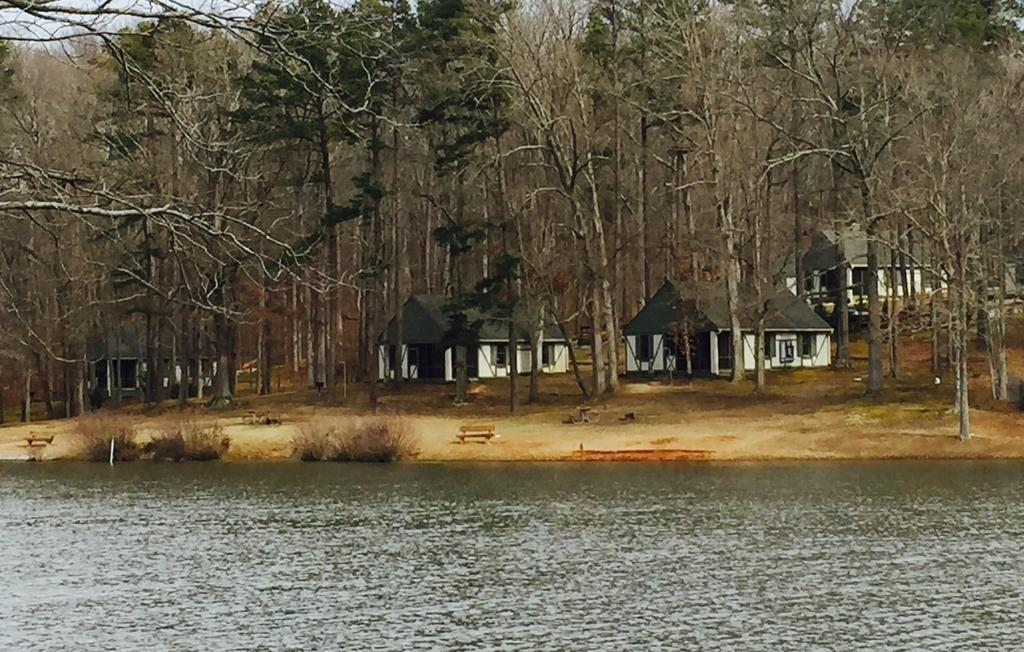Where was the image taken? The image was clicked outside. What can be seen at the bottom of the image? There is water at the bottom of the image. What structures are located in the middle of the image? There are houses and trees in the middle of the image. What type of patch can be seen on the owl's wing in the image? There is no owl present in the image, so it is not possible to determine if there is a patch on its wing. 